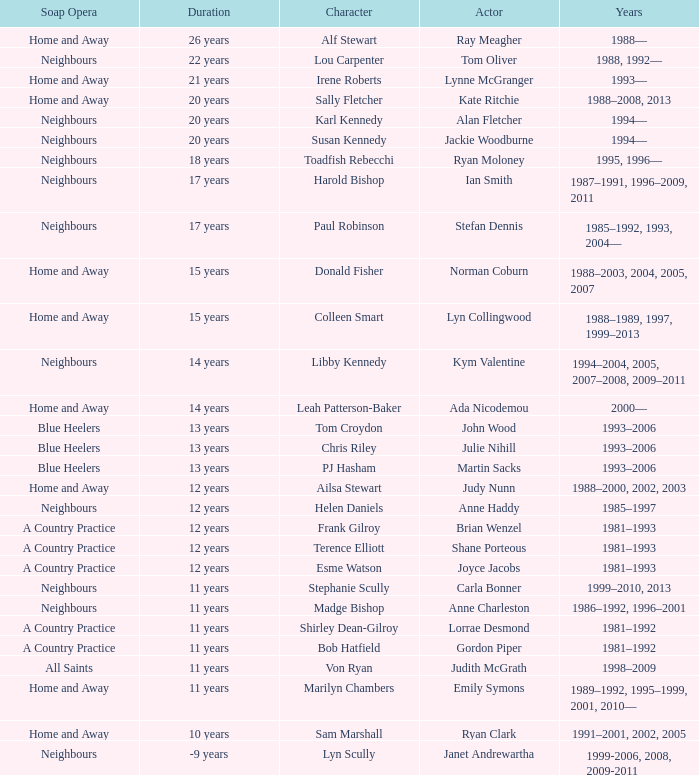What character was portrayed by the same actor for 12 years on Neighbours? Helen Daniels. 